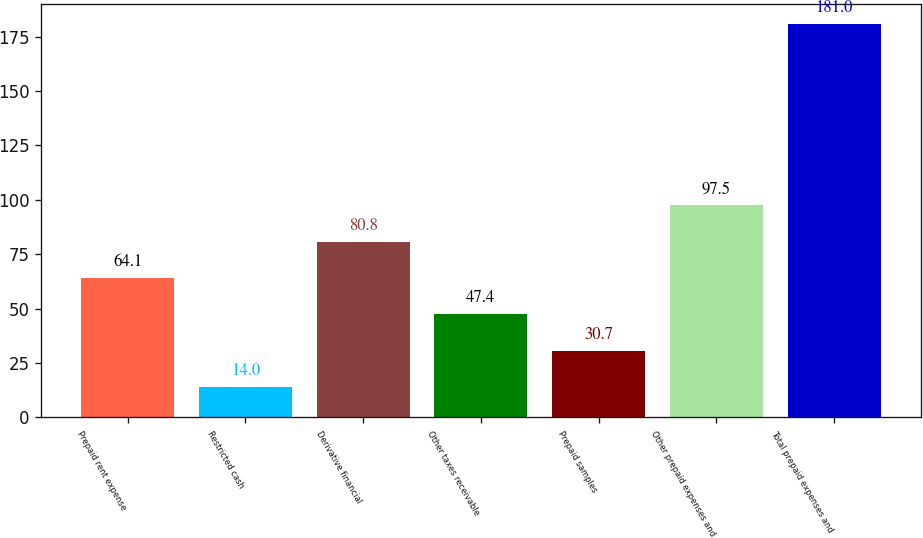Convert chart. <chart><loc_0><loc_0><loc_500><loc_500><bar_chart><fcel>Prepaid rent expense<fcel>Restricted cash<fcel>Derivative financial<fcel>Other taxes receivable<fcel>Prepaid samples<fcel>Other prepaid expenses and<fcel>Total prepaid expenses and<nl><fcel>64.1<fcel>14<fcel>80.8<fcel>47.4<fcel>30.7<fcel>97.5<fcel>181<nl></chart> 